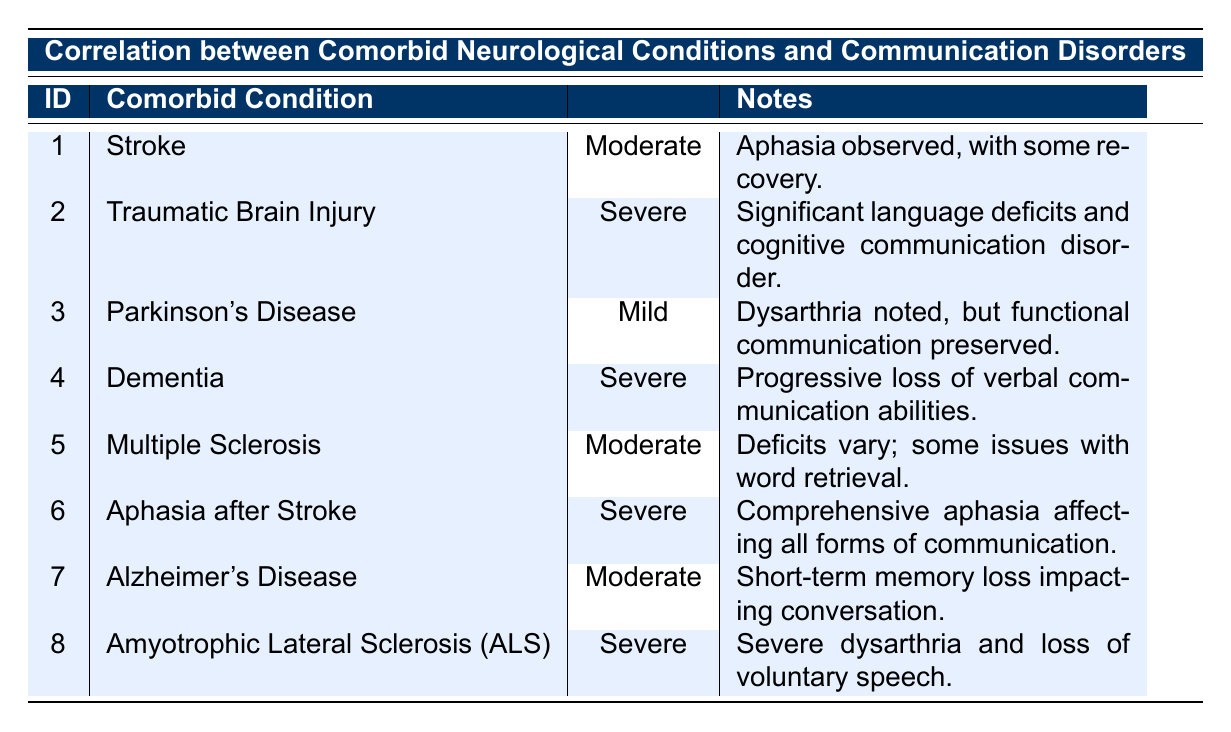What is the severity of communication disorder for the patient with Alzheimer's Disease? The patient with Alzheimer's Disease is listed under PatientID 7, and the corresponding severity of communication disorder is Moderate according to the table.
Answer: Moderate How many patients have a Severe severity of communication disorder? There are four patients with Severe severity indicated: PatientID 2 (Traumatic Brain Injury), PatientID 4 (Dementia), PatientID 6 (Aphasia after Stroke), and PatientID 8 (Amyotrophic Lateral Sclerosis). Therefore, there are 4 patients.
Answer: 4 Is there a patient with Parkinson's Disease who has a Severe severity of communication disorder? The table shows that the patient with Parkinson's Disease (PatientID 3) has a Mild severity, thus confirming there is no patient with Parkinson's Disease with a Severe severity of communication disorder.
Answer: No What is the most common comorbid condition associated with Severe severity of communication disorders based on this data? Looking through the table, we find that the comorbid conditions with Severe severity are Traumatic Brain Injury, Dementia, Aphasia after Stroke, and Amyotrophic Lateral Sclerosis, with no category showing dominance since each appears only once. Thus, no specific comorbid condition claims a majority.
Answer: None What is the overall trend in severity of communication disorders for patients with significant neurological conditions? Analyzing the severity levels: 4 patients have Severe severity, 3 have Moderate severity, and 1 has Mild severity. Most patients show Severe or Moderate severity, suggesting that significant neurological conditions generally correlate with higher severity of communication disorders.
Answer: Higher severity is common How do patients with Moderate severity compare in terms of comorbid conditions? There are three patients with Moderate severity: PatientID 1 (Stroke), PatientID 5 (Multiple Sclerosis), and PatientID 7 (Alzheimer's Disease). The comparison indicates that these conditions are associated with moderate levels of communication disorders.
Answer: 3 patients What is the primary communication disorder noted for patient number 6? According to the table, PatientID 6 has a comorbid condition of Aphasia after Stroke, and the primary communication disorder noted is comprehensive aphasia affecting all forms of communication.
Answer: Comprehensive aphasia How many comorbid conditions involve a mention of progressive loss in communication abilities? Only one condition, Dementia (PatientID 4), mentions a progressive loss of verbal communication abilities. Therefore, the total is 1.
Answer: 1 